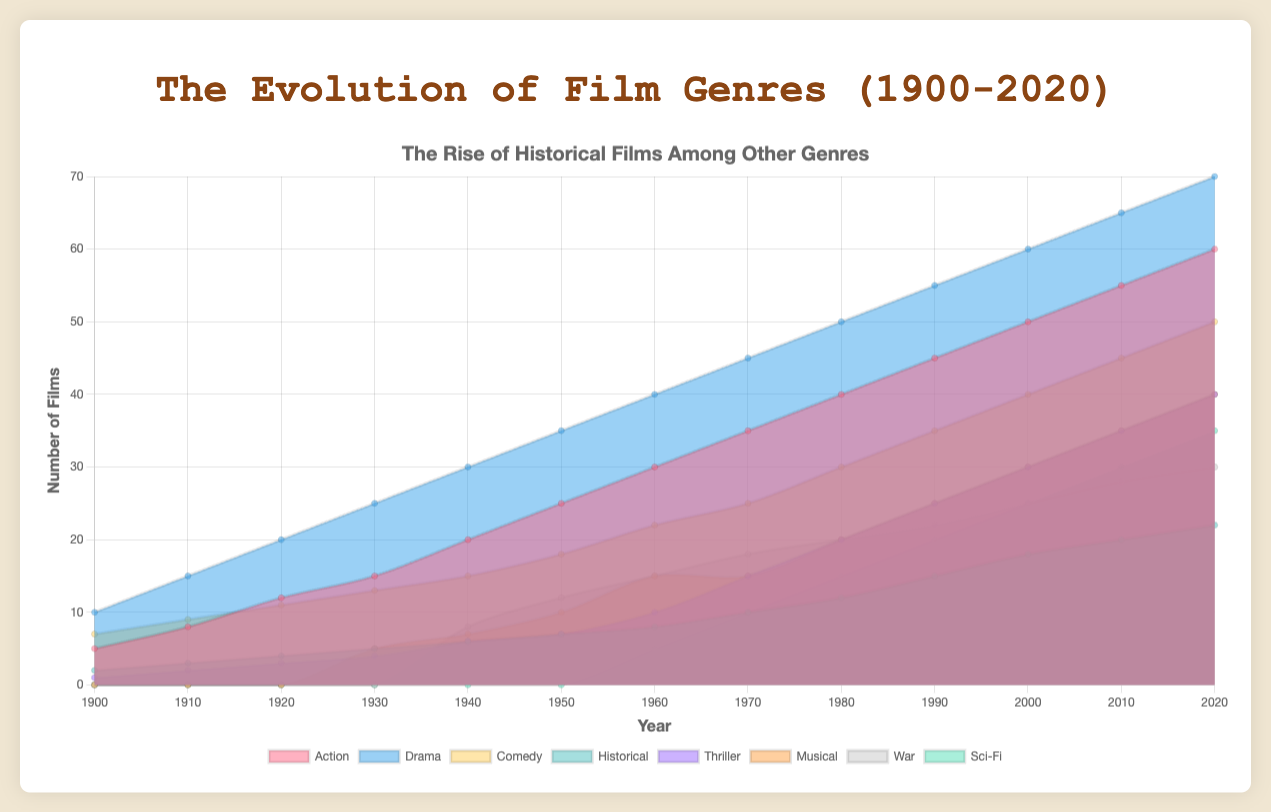What is the title of the chart? The title of the chart is written clearly at the top.
Answer: The Evolution of Film Genres (1900-2020) Which genre had the highest number of films in 1920? By looking at the height of the individual areas in 1920, we can see that the 'silent' genre had the highest number of films.
Answer: Silent How many historical films were made in 1950? The height of the 'historical' area in 1950 corresponds to the number of historical films made that year.
Answer: 7 Compare the number of action films and thriller films in 2000. Which genre had more films? By comparing the height of 'action' and 'thriller' areas in 2000, we can see that 'action' had a higher count.
Answer: Action Has the number of historical films increased or decreased from 1900 to 2020? By tracking the 'historical' area from 1900 to 2020, we see a general increase in the number of films over this period.
Answer: Increased Which decade saw the introduction of the 'sci-fi' genre according to the chart? By looking at the first appearance of the 'sci-fi' area, we can identify that it starts appearing in the 1960s.
Answer: 1960s What is the approximate difference in the number of historical films made between 1910 and 1970? The number of historical films in 1910 was 3, and in 1970 it was 10. The difference is 10 - 3.
Answer: 7 In which year did the war genre first appear on the chart? The 'war' genre first appears in 1940 as indicated by the small area starting to be visible.
Answer: 1940 What are the trends in the number of 'musical' films from 1930 to 2020? 'Musical' films started in 1930 and generally increased over the years, showing significant growth especially post-1950.
Answer: Increasing trend 